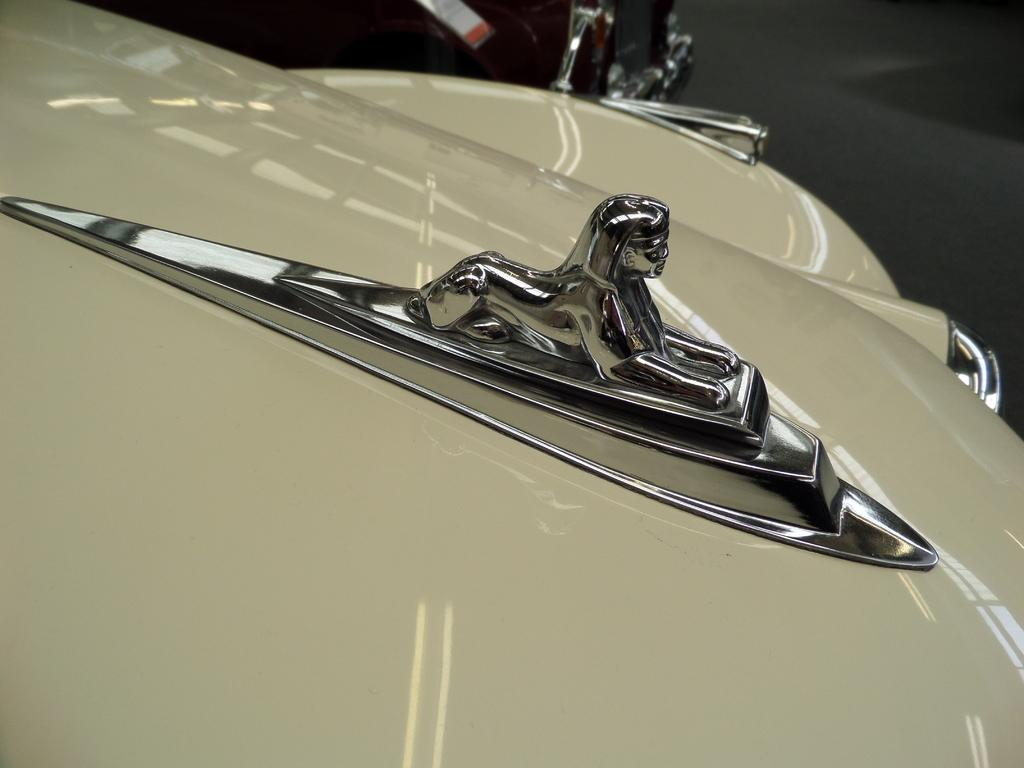What is the main subject of the image? The main subject of the image is a car. Are there any specific details about the car that can be seen in the image? Yes, car logos are visible on the car. How many quarters can be seen on the car's tires in the image? There are no quarters visible on the car's tires in the image. Did the car experience an earthquake while parked, causing damage to its legs? The image does not show any damage to the car's legs, and there is no indication of an earthquake occurring. 